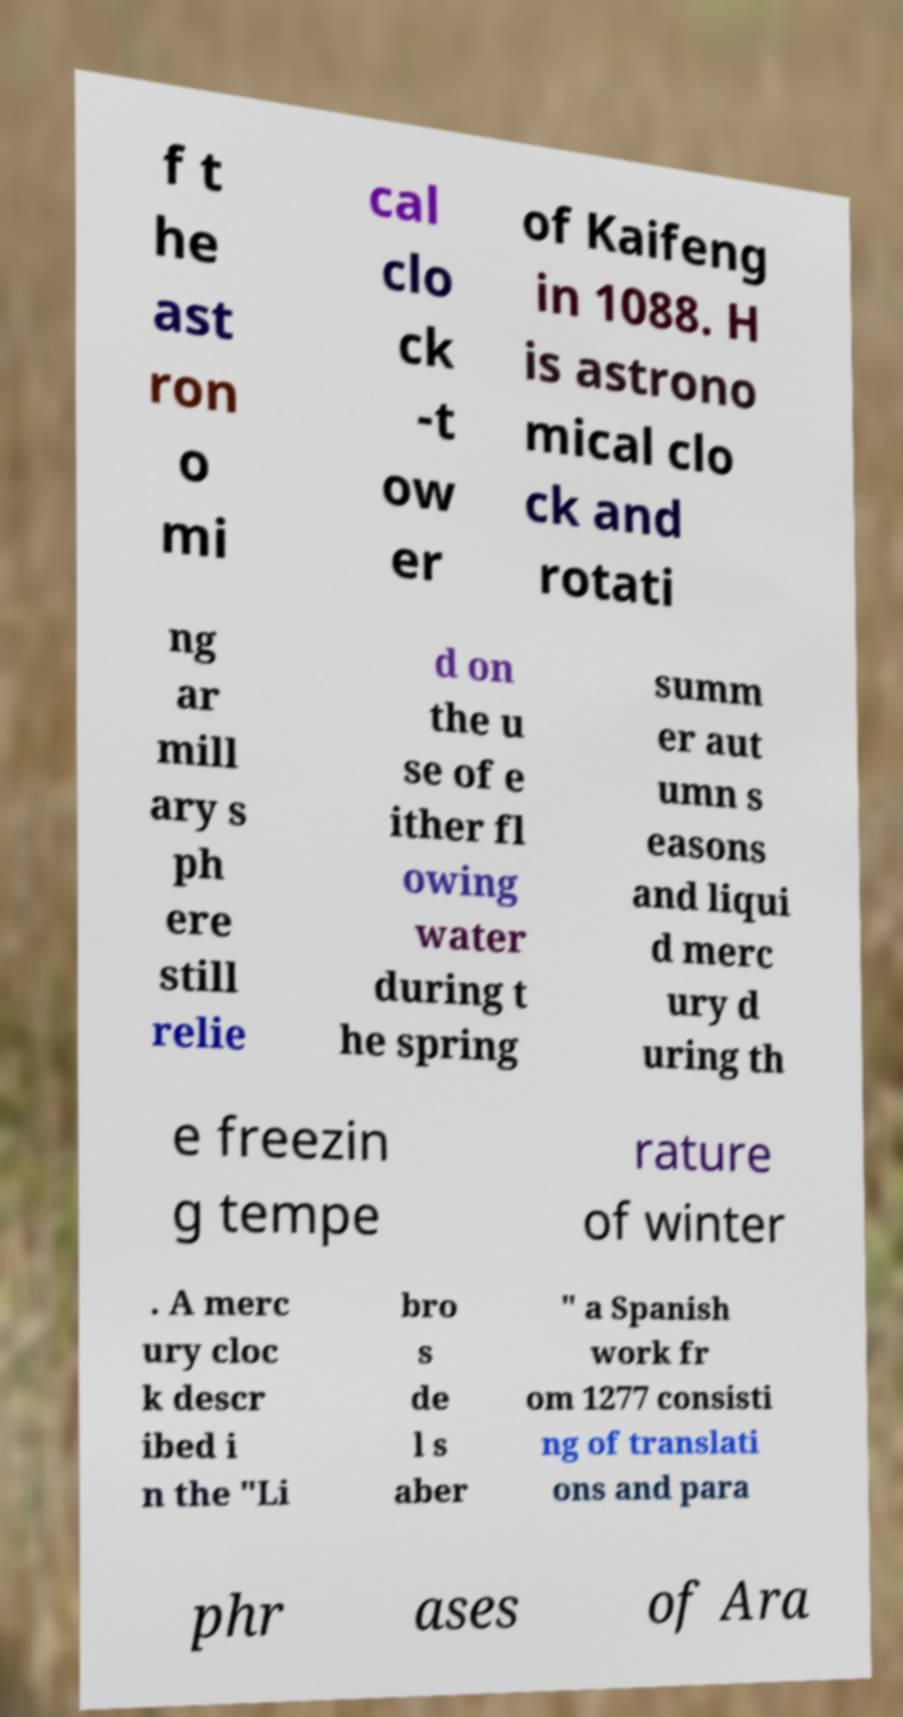Can you read and provide the text displayed in the image?This photo seems to have some interesting text. Can you extract and type it out for me? f t he ast ron o mi cal clo ck -t ow er of Kaifeng in 1088. H is astrono mical clo ck and rotati ng ar mill ary s ph ere still relie d on the u se of e ither fl owing water during t he spring summ er aut umn s easons and liqui d merc ury d uring th e freezin g tempe rature of winter . A merc ury cloc k descr ibed i n the "Li bro s de l s aber " a Spanish work fr om 1277 consisti ng of translati ons and para phr ases of Ara 